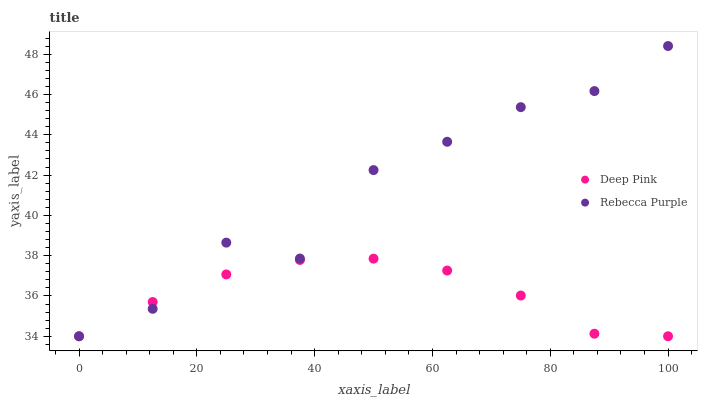Does Deep Pink have the minimum area under the curve?
Answer yes or no. Yes. Does Rebecca Purple have the maximum area under the curve?
Answer yes or no. Yes. Does Rebecca Purple have the minimum area under the curve?
Answer yes or no. No. Is Deep Pink the smoothest?
Answer yes or no. Yes. Is Rebecca Purple the roughest?
Answer yes or no. Yes. Is Rebecca Purple the smoothest?
Answer yes or no. No. Does Deep Pink have the lowest value?
Answer yes or no. Yes. Does Rebecca Purple have the highest value?
Answer yes or no. Yes. Does Deep Pink intersect Rebecca Purple?
Answer yes or no. Yes. Is Deep Pink less than Rebecca Purple?
Answer yes or no. No. Is Deep Pink greater than Rebecca Purple?
Answer yes or no. No. 